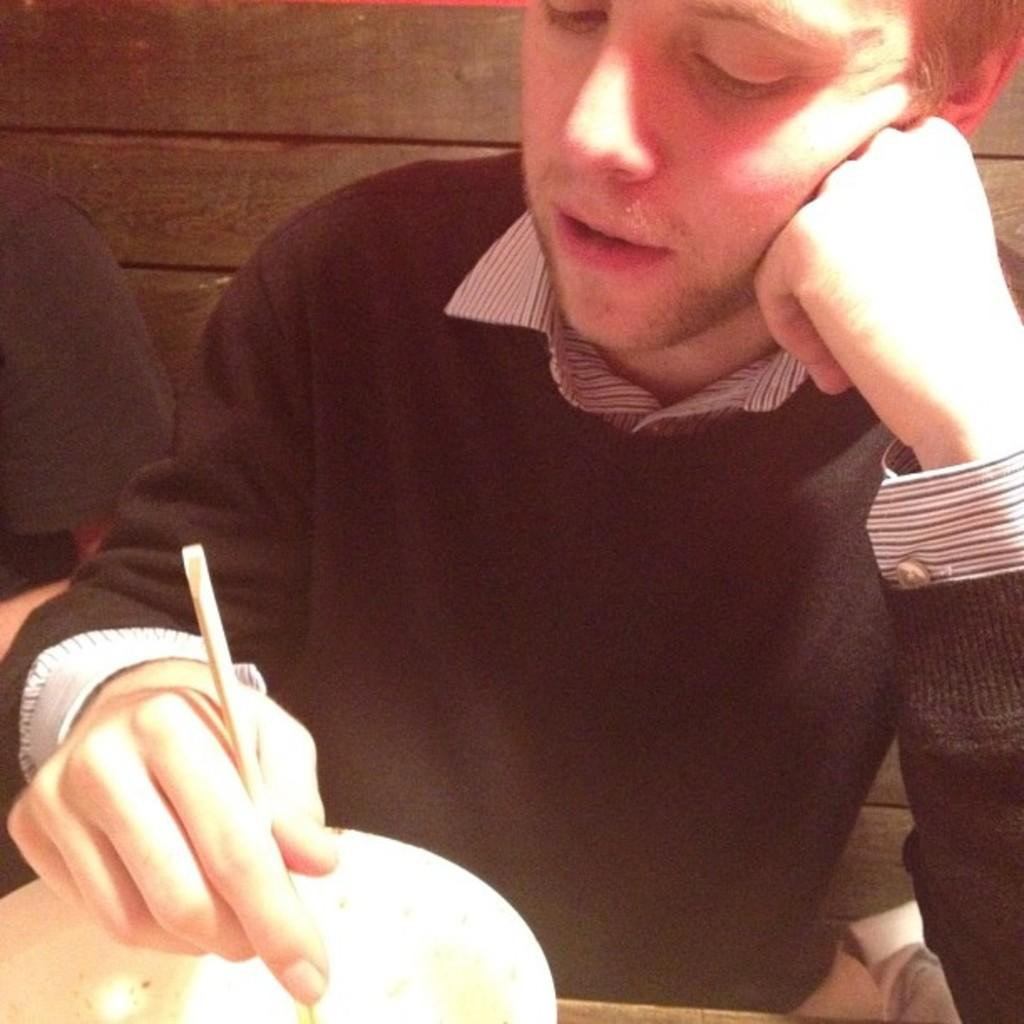Who is in the image? There is a boy in the image. What is the boy wearing? The boy is wearing a black sweater. What is the boy doing in the image? The boy is sitting on a chair and looking into a white food bowl. What can be seen in the background of the image? There is a wooden panel wall in the background. What type of pear is the boy trying to increase in the image? There is no pear present in the image, and the boy is not trying to increase anything. 